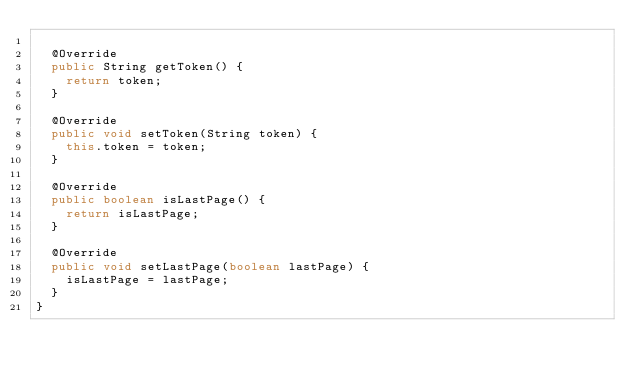<code> <loc_0><loc_0><loc_500><loc_500><_Java_>
  @Override
  public String getToken() {
    return token;
  }

  @Override
  public void setToken(String token) {
    this.token = token;
  }

  @Override
  public boolean isLastPage() {
    return isLastPage;
  }

  @Override
  public void setLastPage(boolean lastPage) {
    isLastPage = lastPage;
  }
}
</code> 